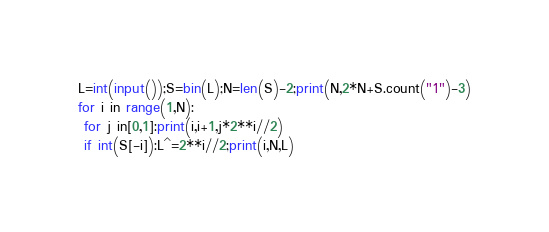Convert code to text. <code><loc_0><loc_0><loc_500><loc_500><_Python_>L=int(input());S=bin(L);N=len(S)-2;print(N,2*N+S.count("1")-3)
for i in range(1,N):
 for j in[0,1]:print(i,i+1,j*2**i//2)
 if int(S[-i]):L^=2**i//2;print(i,N,L)</code> 